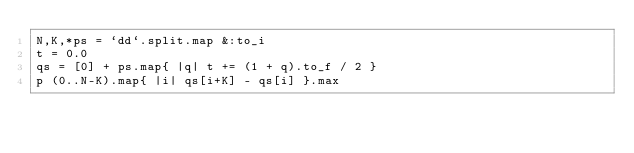<code> <loc_0><loc_0><loc_500><loc_500><_Ruby_>N,K,*ps = `dd`.split.map &:to_i
t = 0.0
qs = [0] + ps.map{ |q| t += (1 + q).to_f / 2 }
p (0..N-K).map{ |i| qs[i+K] - qs[i] }.max</code> 